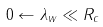<formula> <loc_0><loc_0><loc_500><loc_500>0 \leftarrow \lambda _ { w } \ll R _ { c }</formula> 